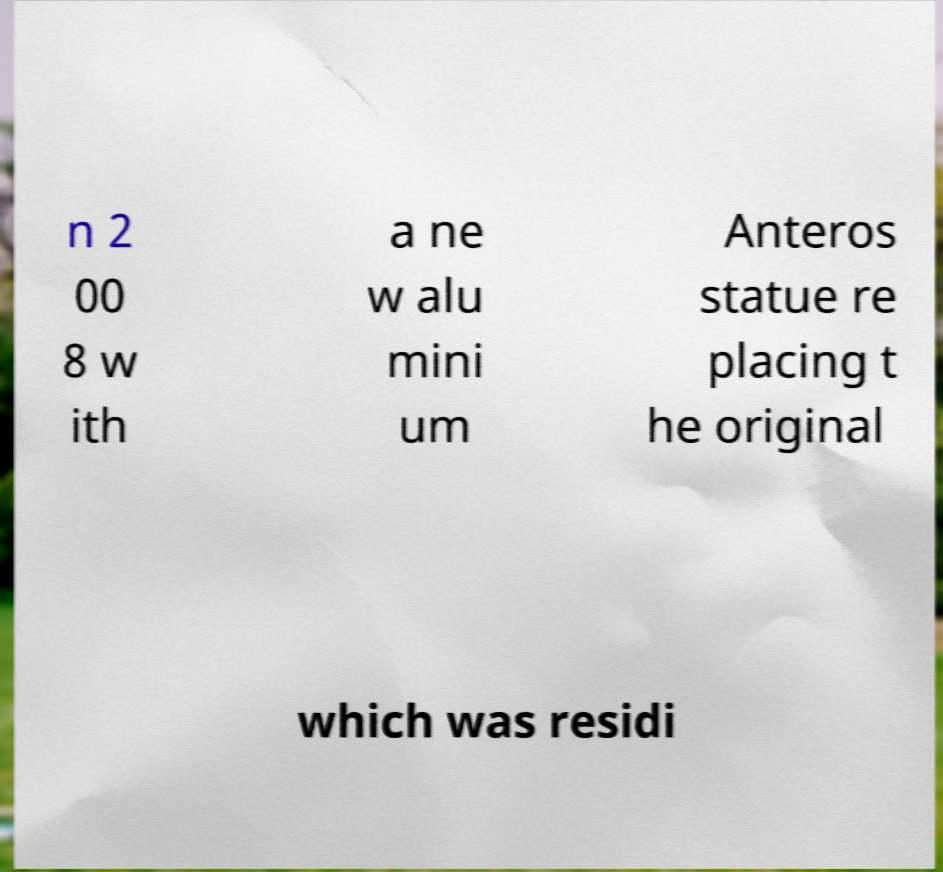Could you assist in decoding the text presented in this image and type it out clearly? n 2 00 8 w ith a ne w alu mini um Anteros statue re placing t he original which was residi 